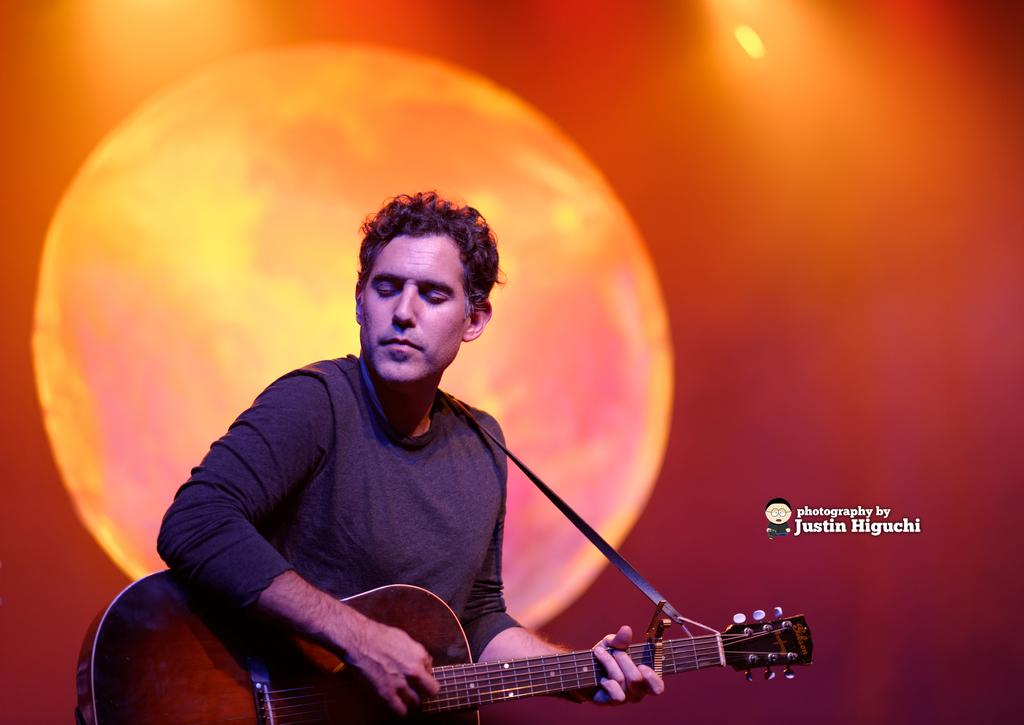What is the man in the image doing? The man is playing a guitar. How is the man interacting with the guitar? The man is holding a guitar. What can be seen in the background of the image? There is a picture of the sun in the background. Are there any cobwebs visible in the image? There is no mention of cobwebs in the provided facts, so we cannot determine if any are present in the image. 